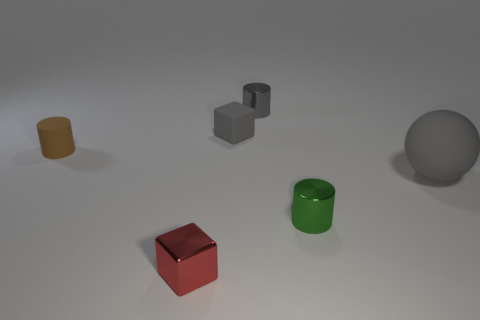Which object in the image appears to have the most textured surface? The small yellow cylinder on the left seems to have the most textured surface, with a slightly rough appearance that stands out from the other objects. 